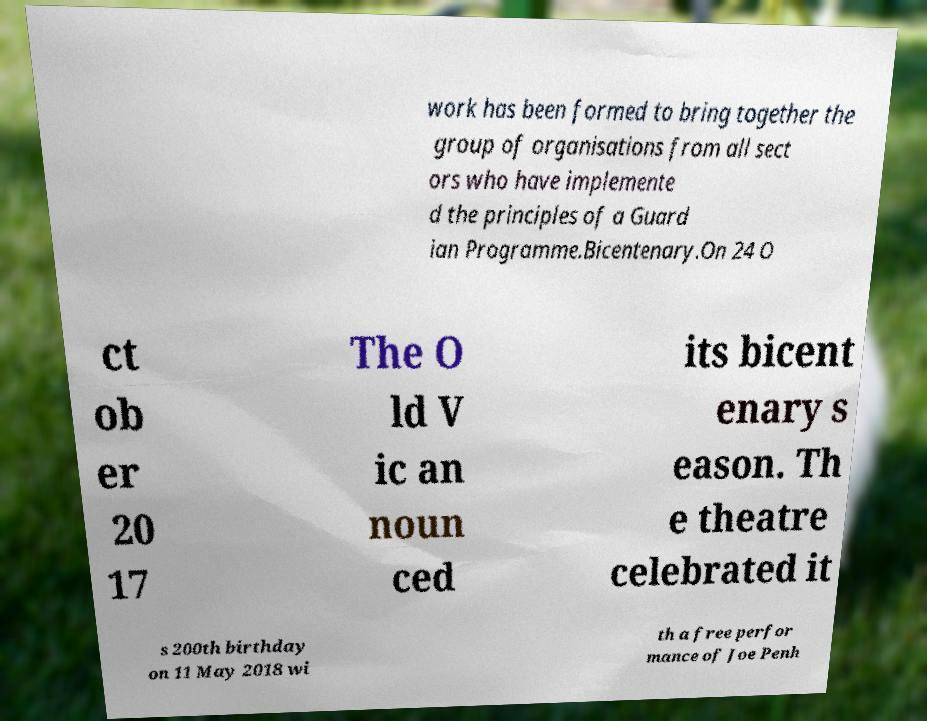Please read and relay the text visible in this image. What does it say? work has been formed to bring together the group of organisations from all sect ors who have implemente d the principles of a Guard ian Programme.Bicentenary.On 24 O ct ob er 20 17 The O ld V ic an noun ced its bicent enary s eason. Th e theatre celebrated it s 200th birthday on 11 May 2018 wi th a free perfor mance of Joe Penh 